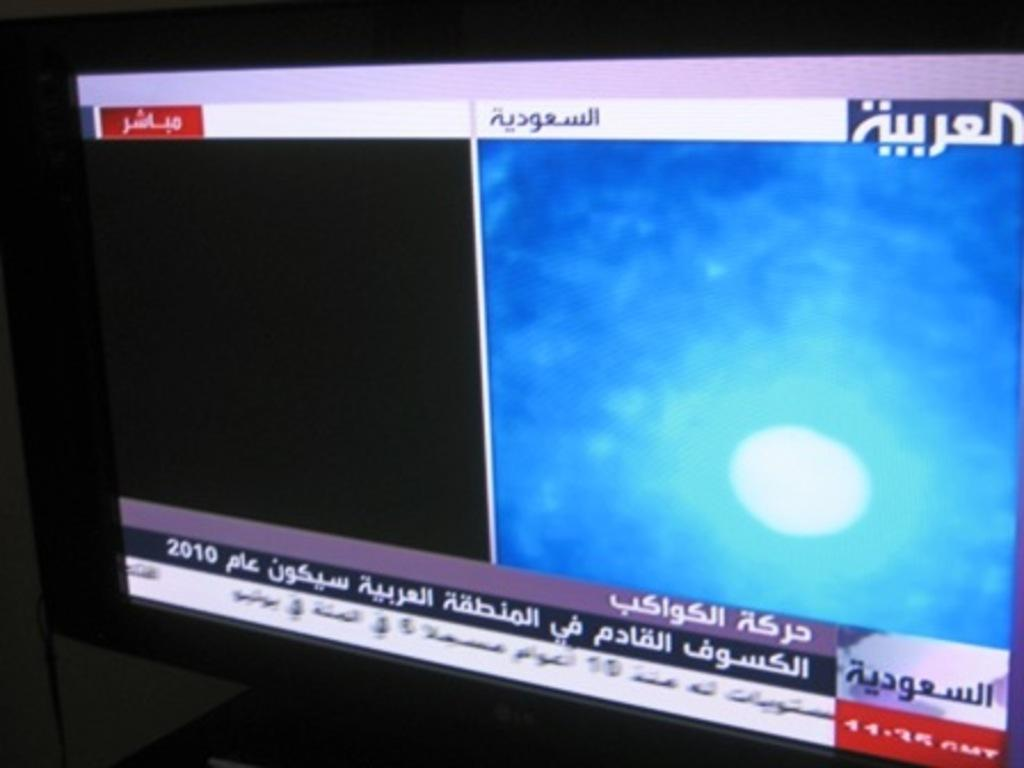<image>
Describe the image concisely. The year 2010 is relevant to the information on the screen. 